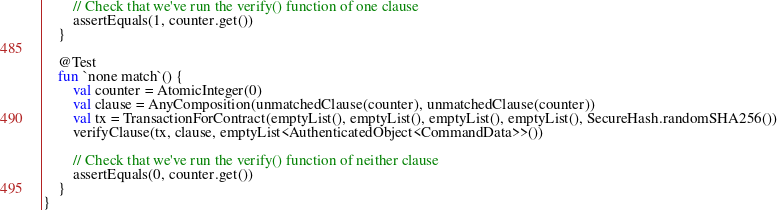<code> <loc_0><loc_0><loc_500><loc_500><_Kotlin_>
        // Check that we've run the verify() function of one clause
        assertEquals(1, counter.get())
    }

    @Test
    fun `none match`() {
        val counter = AtomicInteger(0)
        val clause = AnyComposition(unmatchedClause(counter), unmatchedClause(counter))
        val tx = TransactionForContract(emptyList(), emptyList(), emptyList(), emptyList(), SecureHash.randomSHA256())
        verifyClause(tx, clause, emptyList<AuthenticatedObject<CommandData>>())

        // Check that we've run the verify() function of neither clause
        assertEquals(0, counter.get())
    }
}
</code> 